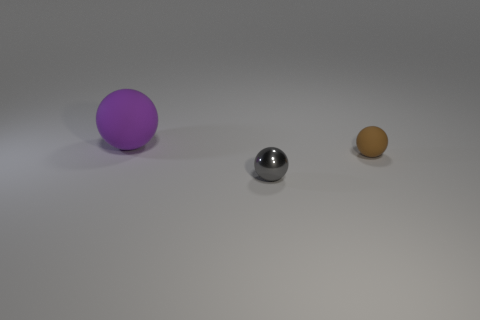Are there any other things that are the same size as the purple rubber object?
Provide a short and direct response. No. Are there an equal number of large purple matte things right of the small gray metallic sphere and small cyan blocks?
Your response must be concise. Yes. What material is the ball in front of the matte object that is to the right of the matte sphere that is on the left side of the gray sphere?
Your answer should be compact. Metal. There is another thing that is the same material as the big thing; what shape is it?
Make the answer very short. Sphere. Is there any other thing that is the same color as the metal thing?
Provide a short and direct response. No. There is a small ball in front of the matte ball that is on the right side of the large rubber thing; how many rubber objects are behind it?
Your answer should be very brief. 2. How many purple things are large matte balls or small metallic balls?
Your answer should be compact. 1. There is a shiny thing; is its size the same as the rubber thing in front of the purple rubber object?
Provide a short and direct response. Yes. There is a tiny brown thing that is the same shape as the gray metallic thing; what is it made of?
Offer a terse response. Rubber. How many other things are the same size as the gray shiny object?
Your answer should be very brief. 1. 